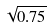Convert formula to latex. <formula><loc_0><loc_0><loc_500><loc_500>\sqrt { 0 . 7 5 }</formula> 